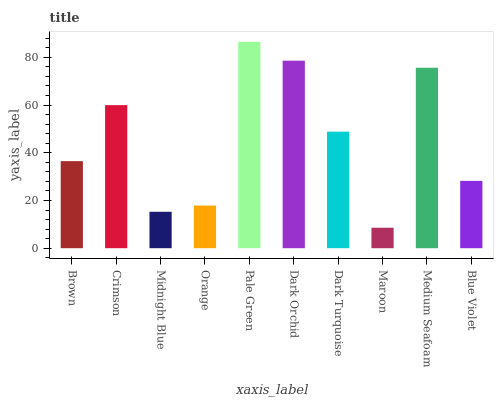Is Maroon the minimum?
Answer yes or no. Yes. Is Pale Green the maximum?
Answer yes or no. Yes. Is Crimson the minimum?
Answer yes or no. No. Is Crimson the maximum?
Answer yes or no. No. Is Crimson greater than Brown?
Answer yes or no. Yes. Is Brown less than Crimson?
Answer yes or no. Yes. Is Brown greater than Crimson?
Answer yes or no. No. Is Crimson less than Brown?
Answer yes or no. No. Is Dark Turquoise the high median?
Answer yes or no. Yes. Is Brown the low median?
Answer yes or no. Yes. Is Blue Violet the high median?
Answer yes or no. No. Is Orange the low median?
Answer yes or no. No. 